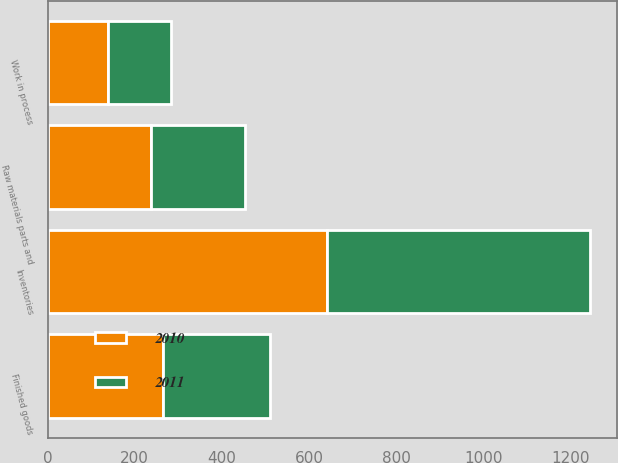<chart> <loc_0><loc_0><loc_500><loc_500><stacked_bar_chart><ecel><fcel>Finished goods<fcel>Work in process<fcel>Raw materials parts and<fcel>Inventories<nl><fcel>2010<fcel>265<fcel>139.4<fcel>237.3<fcel>641.7<nl><fcel>2011<fcel>244.2<fcel>144.1<fcel>215<fcel>603.3<nl></chart> 